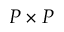<formula> <loc_0><loc_0><loc_500><loc_500>P \times P</formula> 